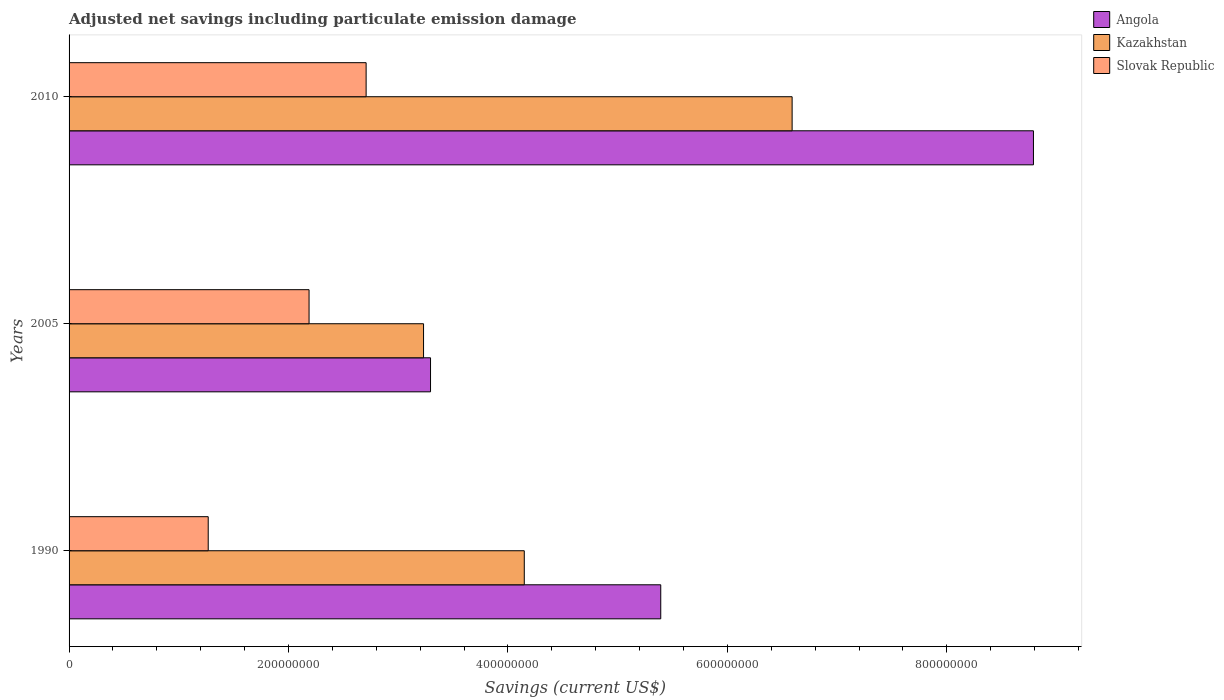Are the number of bars on each tick of the Y-axis equal?
Your answer should be compact. Yes. How many bars are there on the 2nd tick from the bottom?
Provide a short and direct response. 3. What is the net savings in Kazakhstan in 1990?
Your response must be concise. 4.15e+08. Across all years, what is the maximum net savings in Slovak Republic?
Provide a succinct answer. 2.71e+08. Across all years, what is the minimum net savings in Slovak Republic?
Your answer should be very brief. 1.27e+08. In which year was the net savings in Angola maximum?
Offer a very short reply. 2010. What is the total net savings in Slovak Republic in the graph?
Ensure brevity in your answer.  6.16e+08. What is the difference between the net savings in Kazakhstan in 1990 and that in 2005?
Give a very brief answer. 9.18e+07. What is the difference between the net savings in Angola in 2010 and the net savings in Slovak Republic in 2005?
Make the answer very short. 6.60e+08. What is the average net savings in Slovak Republic per year?
Provide a succinct answer. 2.05e+08. In the year 2010, what is the difference between the net savings in Slovak Republic and net savings in Kazakhstan?
Your answer should be very brief. -3.88e+08. What is the ratio of the net savings in Angola in 1990 to that in 2005?
Make the answer very short. 1.64. What is the difference between the highest and the second highest net savings in Slovak Republic?
Your answer should be very brief. 5.20e+07. What is the difference between the highest and the lowest net savings in Kazakhstan?
Provide a succinct answer. 3.36e+08. In how many years, is the net savings in Angola greater than the average net savings in Angola taken over all years?
Offer a very short reply. 1. Is the sum of the net savings in Slovak Republic in 2005 and 2010 greater than the maximum net savings in Kazakhstan across all years?
Your answer should be very brief. No. What does the 1st bar from the top in 2010 represents?
Offer a very short reply. Slovak Republic. What does the 2nd bar from the bottom in 2005 represents?
Your response must be concise. Kazakhstan. How many bars are there?
Offer a terse response. 9. Are all the bars in the graph horizontal?
Offer a terse response. Yes. How many years are there in the graph?
Give a very brief answer. 3. What is the difference between two consecutive major ticks on the X-axis?
Offer a very short reply. 2.00e+08. Does the graph contain grids?
Ensure brevity in your answer.  No. Where does the legend appear in the graph?
Ensure brevity in your answer.  Top right. What is the title of the graph?
Make the answer very short. Adjusted net savings including particulate emission damage. What is the label or title of the X-axis?
Your answer should be very brief. Savings (current US$). What is the Savings (current US$) in Angola in 1990?
Provide a succinct answer. 5.39e+08. What is the Savings (current US$) in Kazakhstan in 1990?
Offer a terse response. 4.15e+08. What is the Savings (current US$) in Slovak Republic in 1990?
Offer a very short reply. 1.27e+08. What is the Savings (current US$) of Angola in 2005?
Give a very brief answer. 3.29e+08. What is the Savings (current US$) of Kazakhstan in 2005?
Your answer should be compact. 3.23e+08. What is the Savings (current US$) in Slovak Republic in 2005?
Provide a succinct answer. 2.19e+08. What is the Savings (current US$) of Angola in 2010?
Provide a succinct answer. 8.79e+08. What is the Savings (current US$) of Kazakhstan in 2010?
Offer a very short reply. 6.59e+08. What is the Savings (current US$) of Slovak Republic in 2010?
Give a very brief answer. 2.71e+08. Across all years, what is the maximum Savings (current US$) of Angola?
Provide a short and direct response. 8.79e+08. Across all years, what is the maximum Savings (current US$) in Kazakhstan?
Provide a succinct answer. 6.59e+08. Across all years, what is the maximum Savings (current US$) in Slovak Republic?
Give a very brief answer. 2.71e+08. Across all years, what is the minimum Savings (current US$) of Angola?
Ensure brevity in your answer.  3.29e+08. Across all years, what is the minimum Savings (current US$) of Kazakhstan?
Provide a short and direct response. 3.23e+08. Across all years, what is the minimum Savings (current US$) of Slovak Republic?
Keep it short and to the point. 1.27e+08. What is the total Savings (current US$) in Angola in the graph?
Offer a terse response. 1.75e+09. What is the total Savings (current US$) in Kazakhstan in the graph?
Keep it short and to the point. 1.40e+09. What is the total Savings (current US$) in Slovak Republic in the graph?
Offer a terse response. 6.16e+08. What is the difference between the Savings (current US$) of Angola in 1990 and that in 2005?
Provide a succinct answer. 2.10e+08. What is the difference between the Savings (current US$) of Kazakhstan in 1990 and that in 2005?
Ensure brevity in your answer.  9.18e+07. What is the difference between the Savings (current US$) of Slovak Republic in 1990 and that in 2005?
Ensure brevity in your answer.  -9.19e+07. What is the difference between the Savings (current US$) of Angola in 1990 and that in 2010?
Keep it short and to the point. -3.40e+08. What is the difference between the Savings (current US$) of Kazakhstan in 1990 and that in 2010?
Make the answer very short. -2.44e+08. What is the difference between the Savings (current US$) of Slovak Republic in 1990 and that in 2010?
Provide a short and direct response. -1.44e+08. What is the difference between the Savings (current US$) of Angola in 2005 and that in 2010?
Your response must be concise. -5.49e+08. What is the difference between the Savings (current US$) in Kazakhstan in 2005 and that in 2010?
Give a very brief answer. -3.36e+08. What is the difference between the Savings (current US$) in Slovak Republic in 2005 and that in 2010?
Provide a succinct answer. -5.20e+07. What is the difference between the Savings (current US$) of Angola in 1990 and the Savings (current US$) of Kazakhstan in 2005?
Provide a succinct answer. 2.16e+08. What is the difference between the Savings (current US$) of Angola in 1990 and the Savings (current US$) of Slovak Republic in 2005?
Offer a terse response. 3.21e+08. What is the difference between the Savings (current US$) in Kazakhstan in 1990 and the Savings (current US$) in Slovak Republic in 2005?
Offer a very short reply. 1.96e+08. What is the difference between the Savings (current US$) of Angola in 1990 and the Savings (current US$) of Kazakhstan in 2010?
Provide a short and direct response. -1.20e+08. What is the difference between the Savings (current US$) in Angola in 1990 and the Savings (current US$) in Slovak Republic in 2010?
Your response must be concise. 2.69e+08. What is the difference between the Savings (current US$) in Kazakhstan in 1990 and the Savings (current US$) in Slovak Republic in 2010?
Your response must be concise. 1.44e+08. What is the difference between the Savings (current US$) of Angola in 2005 and the Savings (current US$) of Kazakhstan in 2010?
Give a very brief answer. -3.30e+08. What is the difference between the Savings (current US$) of Angola in 2005 and the Savings (current US$) of Slovak Republic in 2010?
Offer a very short reply. 5.87e+07. What is the difference between the Savings (current US$) in Kazakhstan in 2005 and the Savings (current US$) in Slovak Republic in 2010?
Keep it short and to the point. 5.23e+07. What is the average Savings (current US$) in Angola per year?
Offer a very short reply. 5.83e+08. What is the average Savings (current US$) in Kazakhstan per year?
Your answer should be compact. 4.66e+08. What is the average Savings (current US$) in Slovak Republic per year?
Provide a succinct answer. 2.05e+08. In the year 1990, what is the difference between the Savings (current US$) in Angola and Savings (current US$) in Kazakhstan?
Provide a short and direct response. 1.24e+08. In the year 1990, what is the difference between the Savings (current US$) in Angola and Savings (current US$) in Slovak Republic?
Offer a terse response. 4.12e+08. In the year 1990, what is the difference between the Savings (current US$) in Kazakhstan and Savings (current US$) in Slovak Republic?
Your answer should be very brief. 2.88e+08. In the year 2005, what is the difference between the Savings (current US$) in Angola and Savings (current US$) in Kazakhstan?
Offer a very short reply. 6.37e+06. In the year 2005, what is the difference between the Savings (current US$) in Angola and Savings (current US$) in Slovak Republic?
Offer a terse response. 1.11e+08. In the year 2005, what is the difference between the Savings (current US$) of Kazakhstan and Savings (current US$) of Slovak Republic?
Your response must be concise. 1.04e+08. In the year 2010, what is the difference between the Savings (current US$) in Angola and Savings (current US$) in Kazakhstan?
Your answer should be very brief. 2.20e+08. In the year 2010, what is the difference between the Savings (current US$) of Angola and Savings (current US$) of Slovak Republic?
Provide a short and direct response. 6.08e+08. In the year 2010, what is the difference between the Savings (current US$) of Kazakhstan and Savings (current US$) of Slovak Republic?
Provide a succinct answer. 3.88e+08. What is the ratio of the Savings (current US$) of Angola in 1990 to that in 2005?
Ensure brevity in your answer.  1.64. What is the ratio of the Savings (current US$) of Kazakhstan in 1990 to that in 2005?
Keep it short and to the point. 1.28. What is the ratio of the Savings (current US$) in Slovak Republic in 1990 to that in 2005?
Your response must be concise. 0.58. What is the ratio of the Savings (current US$) in Angola in 1990 to that in 2010?
Provide a short and direct response. 0.61. What is the ratio of the Savings (current US$) of Kazakhstan in 1990 to that in 2010?
Give a very brief answer. 0.63. What is the ratio of the Savings (current US$) in Slovak Republic in 1990 to that in 2010?
Give a very brief answer. 0.47. What is the ratio of the Savings (current US$) of Angola in 2005 to that in 2010?
Provide a short and direct response. 0.37. What is the ratio of the Savings (current US$) of Kazakhstan in 2005 to that in 2010?
Make the answer very short. 0.49. What is the ratio of the Savings (current US$) of Slovak Republic in 2005 to that in 2010?
Offer a very short reply. 0.81. What is the difference between the highest and the second highest Savings (current US$) of Angola?
Ensure brevity in your answer.  3.40e+08. What is the difference between the highest and the second highest Savings (current US$) of Kazakhstan?
Your answer should be very brief. 2.44e+08. What is the difference between the highest and the second highest Savings (current US$) of Slovak Republic?
Keep it short and to the point. 5.20e+07. What is the difference between the highest and the lowest Savings (current US$) of Angola?
Keep it short and to the point. 5.49e+08. What is the difference between the highest and the lowest Savings (current US$) in Kazakhstan?
Ensure brevity in your answer.  3.36e+08. What is the difference between the highest and the lowest Savings (current US$) in Slovak Republic?
Your answer should be very brief. 1.44e+08. 